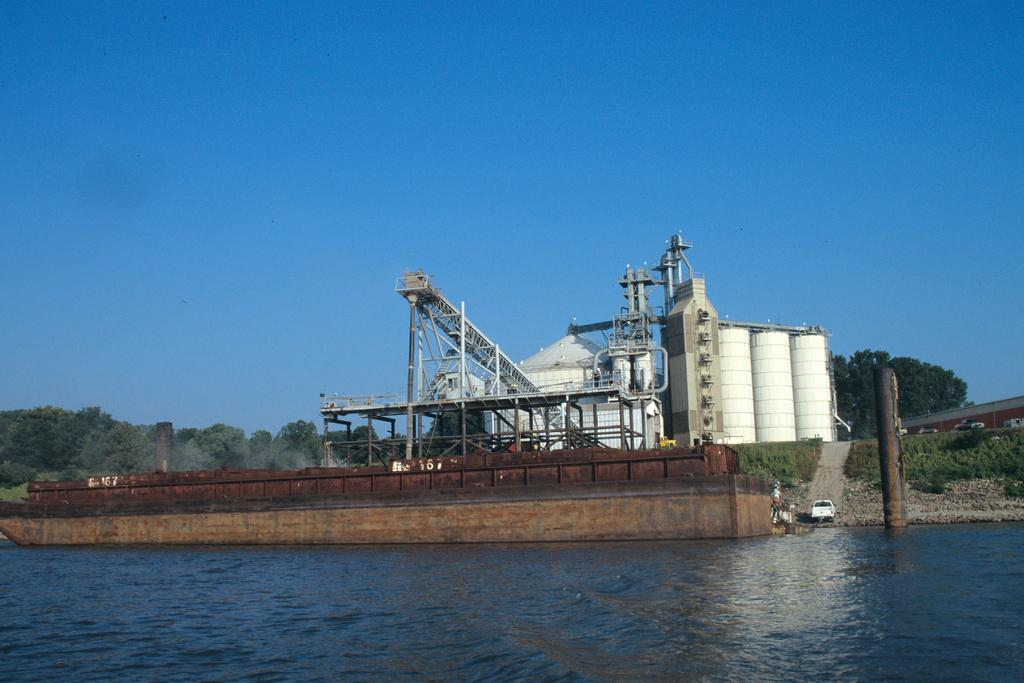What type of structure is present in the image? There is a factory in the image. What else can be seen in the image besides the factory? There is a vehicle and objects on the ground visible in the image. What is the condition of the water in the image? The water is visible in the image. What can be seen in the background of the image? There are trees and the sky visible in the background of the image. What type of toothpaste is being used to clean the vehicle in the image? There is no toothpaste present in the image, and the vehicle is not being cleaned. What color is the straw that the trees are holding in the image? There are no straws present in the image, and trees do not hold objects. 